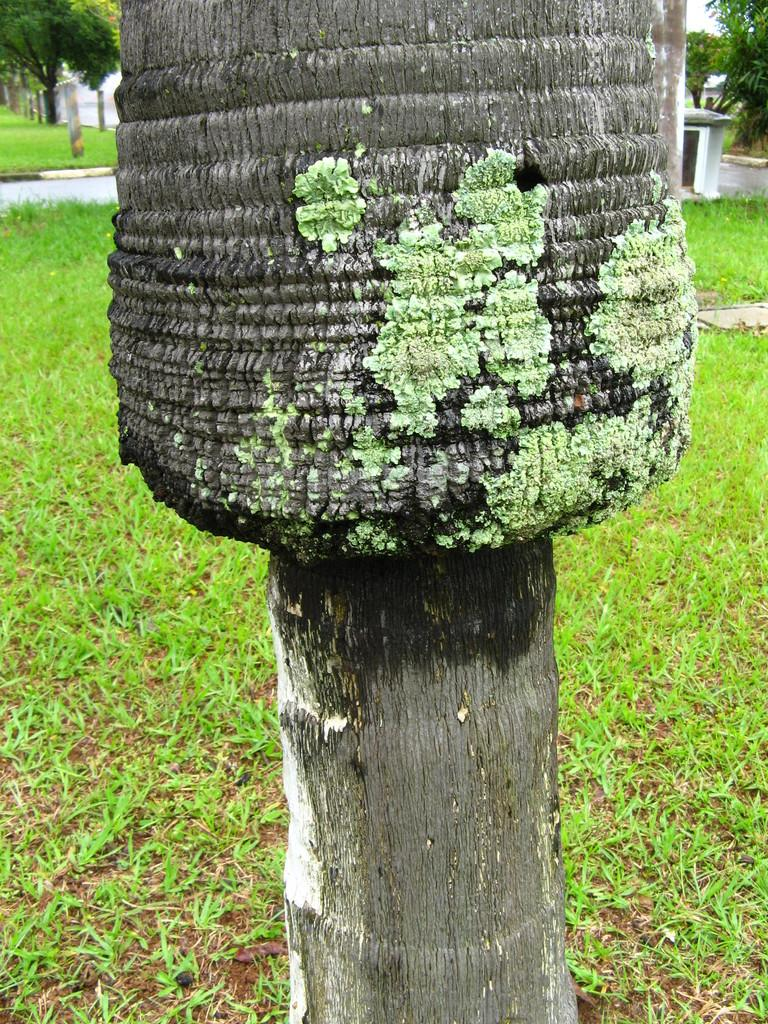What type of vegetation is in the front of the image? There is a tree in the front of the image. What type of ground cover is visible in the center of the image? There is grass on the ground in the center of the image. What can be seen in the background of the image? There are trees and a wall in the background of the image. What type of hat is the son wearing during recess in the image? There is no son or recess present in the image; it features a tree, grass, and a wall in the background. 